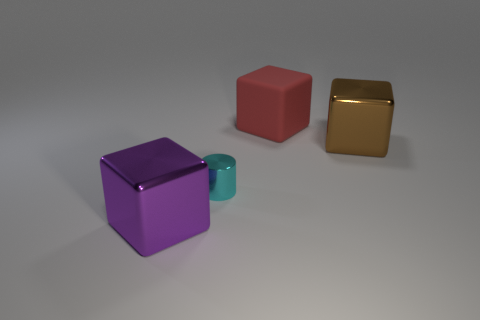There is a large thing that is right of the large rubber cube; is its color the same as the cylinder?
Give a very brief answer. No. Are there any big purple objects made of the same material as the large red cube?
Give a very brief answer. No. How many brown things are either cubes or tiny shiny objects?
Provide a succinct answer. 1. Is the number of large blocks behind the tiny shiny cylinder greater than the number of tiny yellow rubber cylinders?
Provide a short and direct response. Yes. Is the rubber object the same size as the cyan cylinder?
Your answer should be compact. No. There is a cube that is made of the same material as the big purple thing; what is its color?
Make the answer very short. Brown. Is the number of red matte things in front of the purple shiny object the same as the number of small cylinders behind the red rubber object?
Your answer should be compact. Yes. There is a small object behind the block that is in front of the tiny cyan cylinder; what shape is it?
Give a very brief answer. Cylinder. There is a large purple thing that is the same shape as the red rubber object; what is its material?
Your answer should be very brief. Metal. What is the color of the rubber cube that is the same size as the brown thing?
Offer a terse response. Red. 